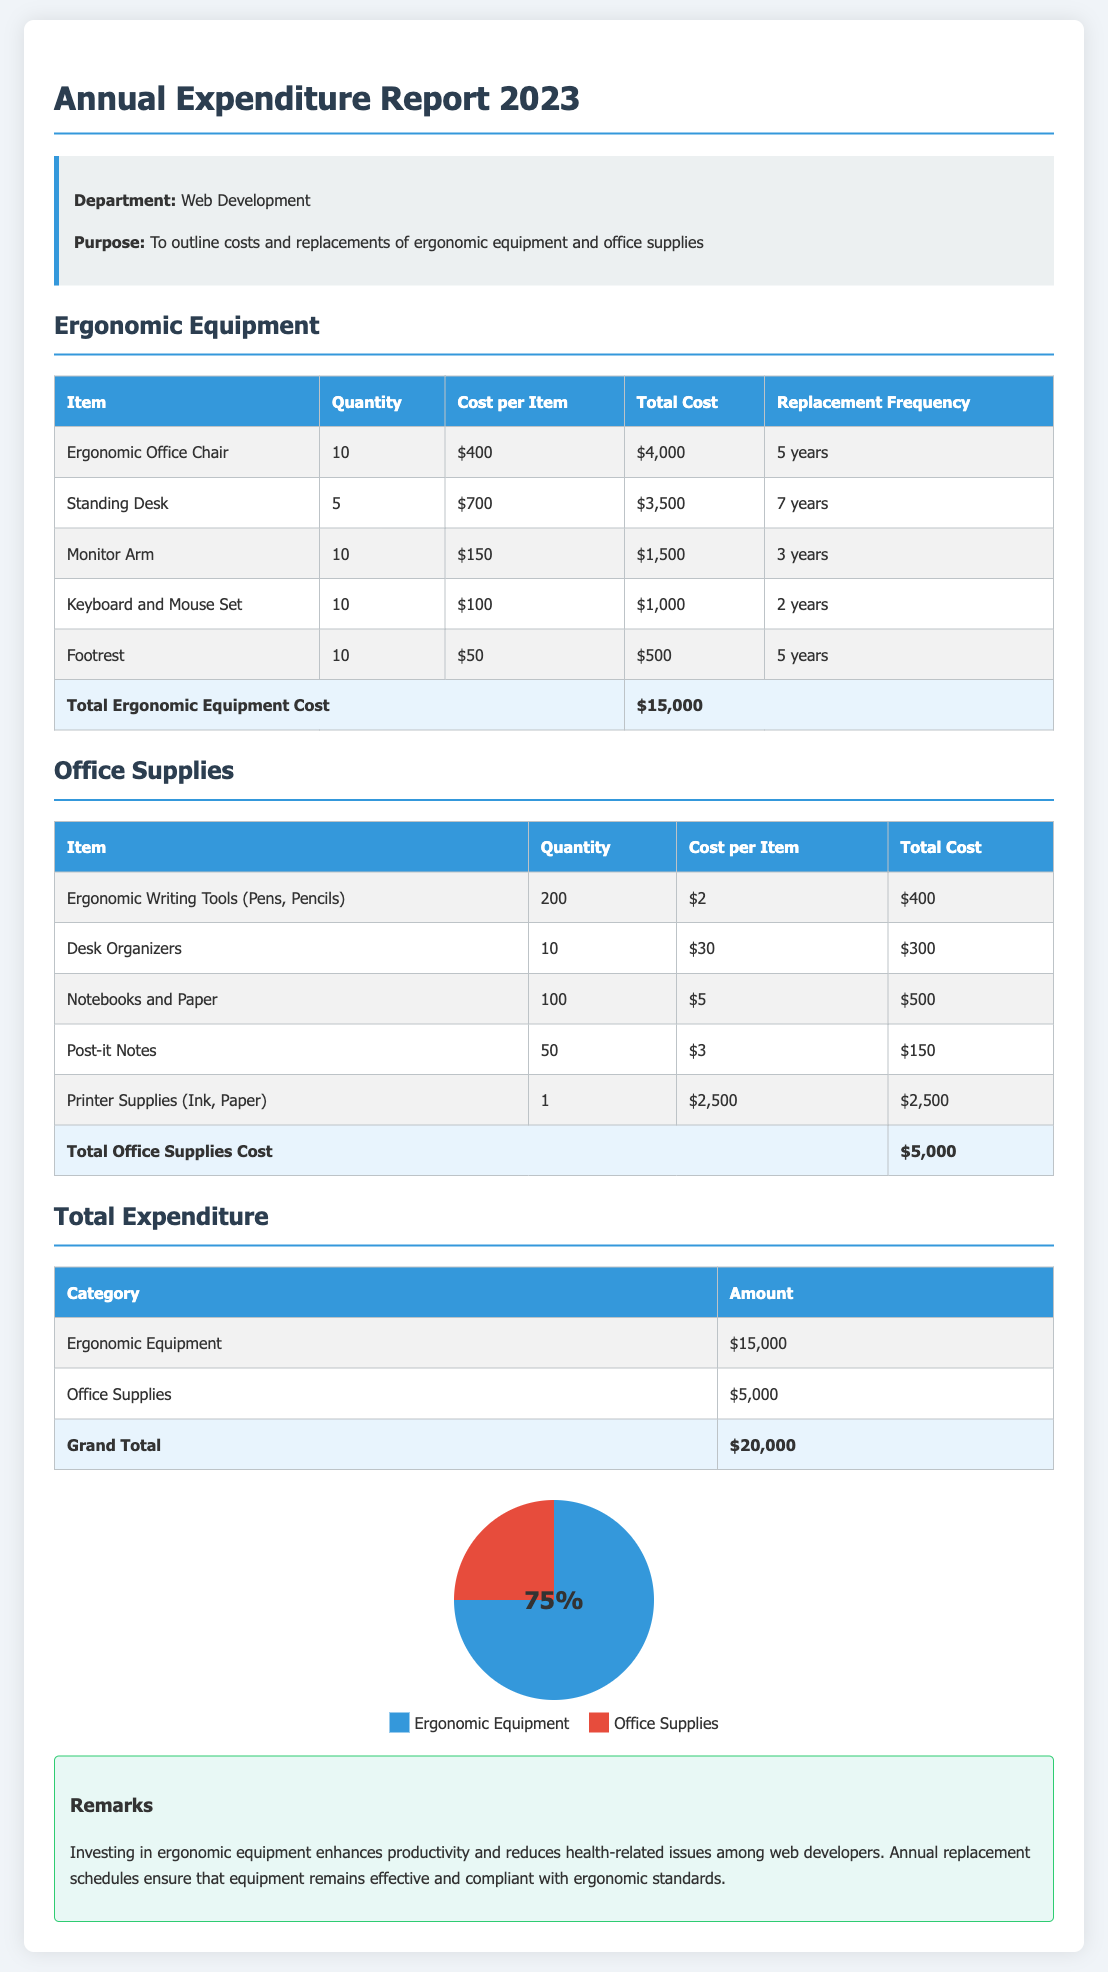What is the total cost for ergonomic office chairs? The total cost for ergonomic office chairs is listed in the table under Ergonomic Equipment. 10 chairs at $400 each equals $4000.
Answer: $4,000 How often are keyboard and mouse sets replaced? The replacement frequency for keyboard and mouse sets is mentioned in the table under Ergonomic Equipment. It states they are replaced every 2 years.
Answer: 2 years What is the total cost of office supplies? The total cost of office supplies is provided at the end of the Office Supplies table, which sums up to $5000.
Answer: $5,000 Which ergonomic equipment has the highest total expenditure? The highest total expenditure is the ergonomic office chairs, which cost $4000.
Answer: Ergonomic Office Chair How much does the company spend in total on ergonomic equipment and office supplies combined? The grand total is calculated by adding the total cost of ergonomic equipment and office supplies, which equals $20,000.
Answer: $20,000 